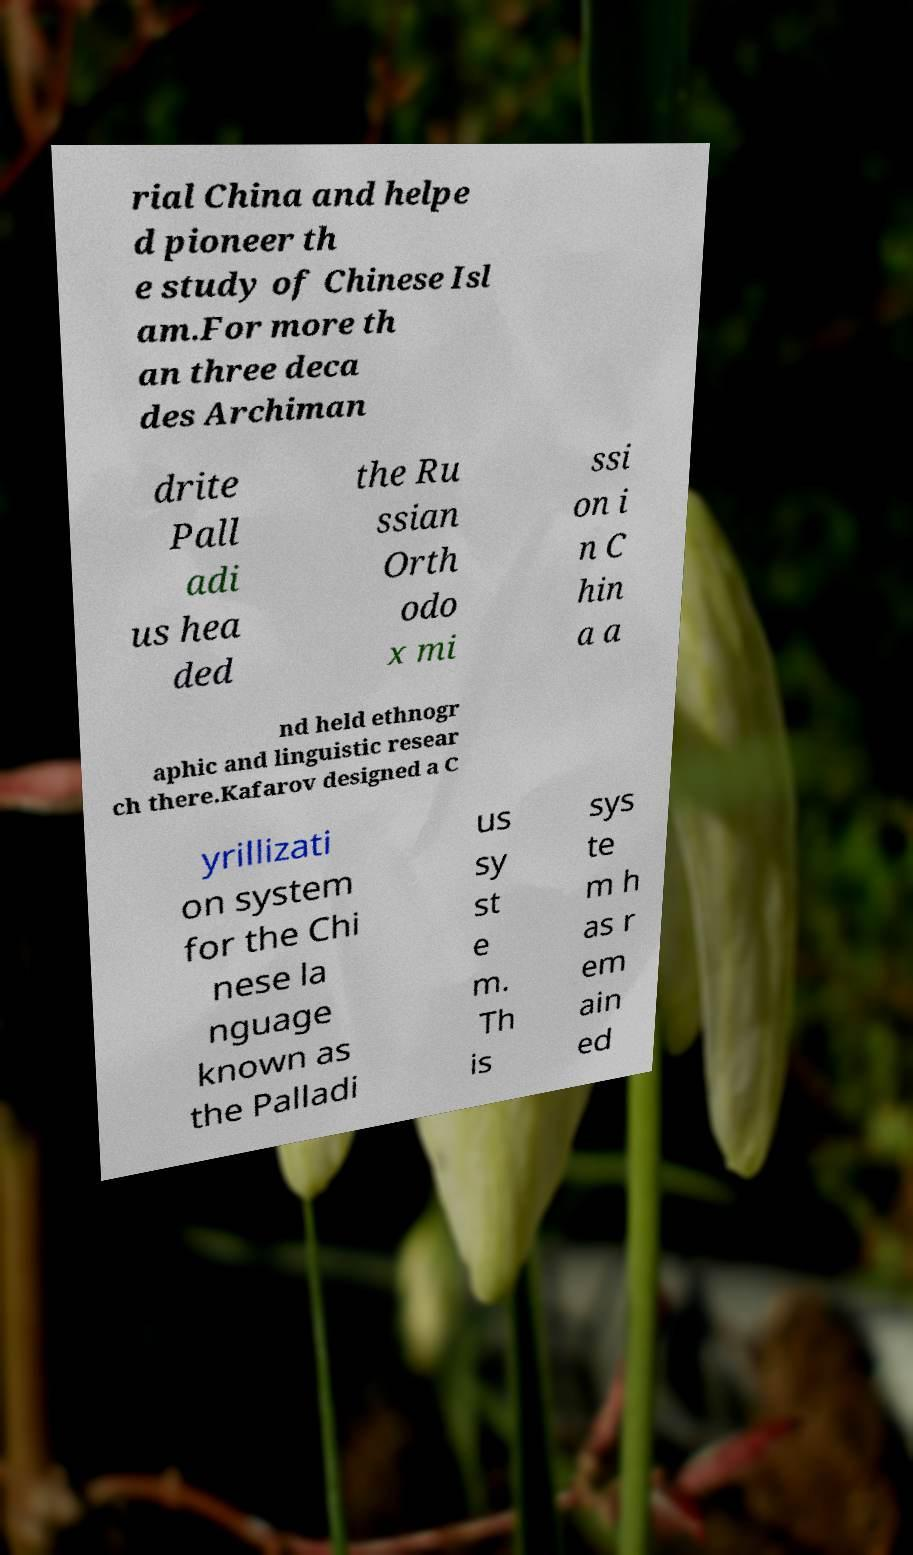Can you read and provide the text displayed in the image?This photo seems to have some interesting text. Can you extract and type it out for me? rial China and helpe d pioneer th e study of Chinese Isl am.For more th an three deca des Archiman drite Pall adi us hea ded the Ru ssian Orth odo x mi ssi on i n C hin a a nd held ethnogr aphic and linguistic resear ch there.Kafarov designed a C yrillizati on system for the Chi nese la nguage known as the Palladi us sy st e m. Th is sys te m h as r em ain ed 